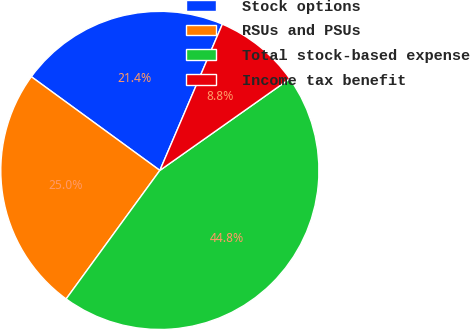Convert chart. <chart><loc_0><loc_0><loc_500><loc_500><pie_chart><fcel>Stock options<fcel>RSUs and PSUs<fcel>Total stock-based expense<fcel>Income tax benefit<nl><fcel>21.4%<fcel>25.0%<fcel>44.81%<fcel>8.79%<nl></chart> 